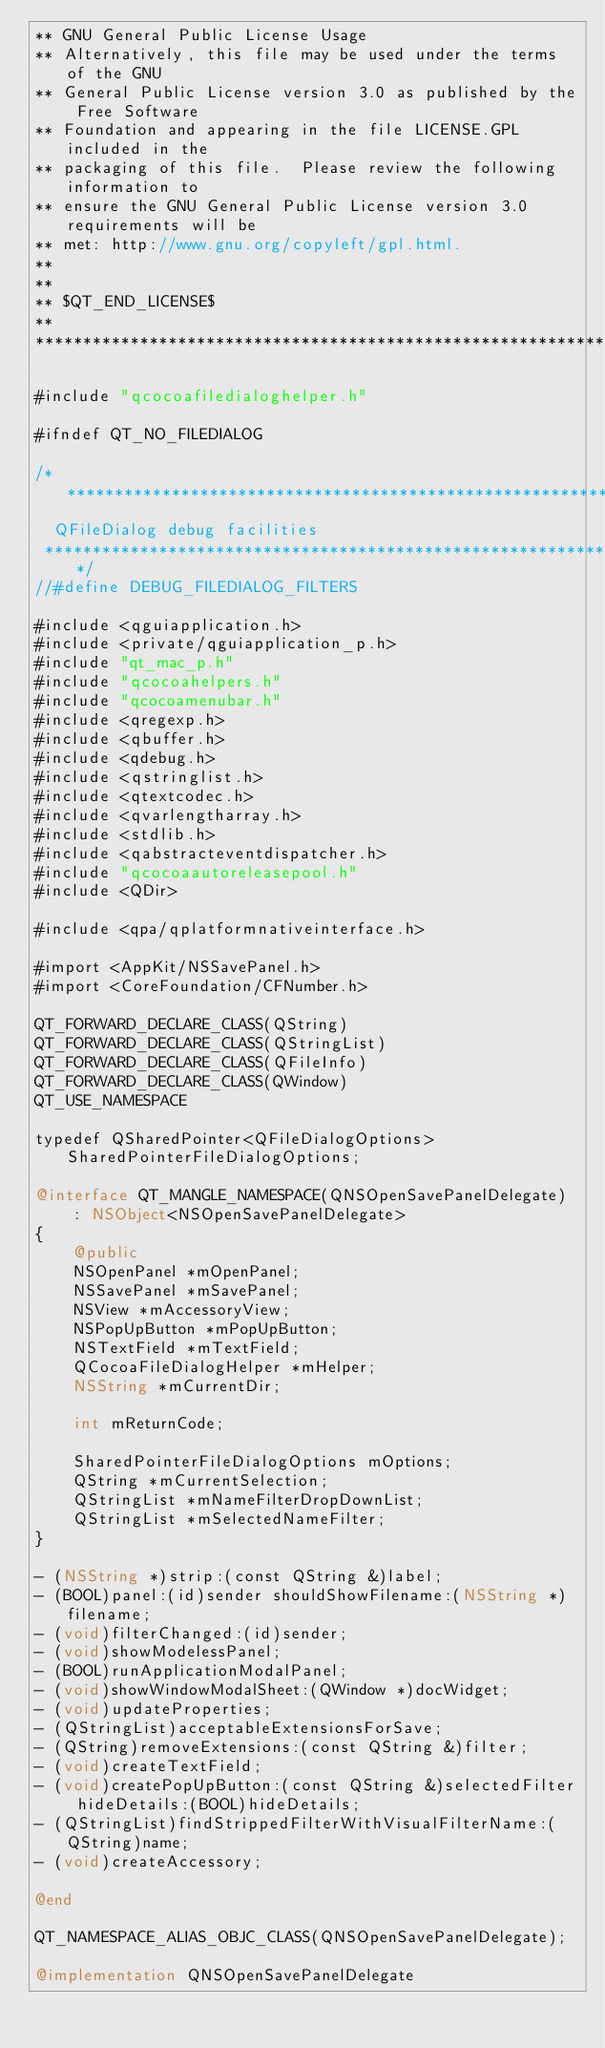Convert code to text. <code><loc_0><loc_0><loc_500><loc_500><_ObjectiveC_>** GNU General Public License Usage
** Alternatively, this file may be used under the terms of the GNU
** General Public License version 3.0 as published by the Free Software
** Foundation and appearing in the file LICENSE.GPL included in the
** packaging of this file.  Please review the following information to
** ensure the GNU General Public License version 3.0 requirements will be
** met: http://www.gnu.org/copyleft/gpl.html.
**
**
** $QT_END_LICENSE$
**
****************************************************************************/

#include "qcocoafiledialoghelper.h"

#ifndef QT_NO_FILEDIALOG

/*****************************************************************************
  QFileDialog debug facilities
 *****************************************************************************/
//#define DEBUG_FILEDIALOG_FILTERS

#include <qguiapplication.h>
#include <private/qguiapplication_p.h>
#include "qt_mac_p.h"
#include "qcocoahelpers.h"
#include "qcocoamenubar.h"
#include <qregexp.h>
#include <qbuffer.h>
#include <qdebug.h>
#include <qstringlist.h>
#include <qtextcodec.h>
#include <qvarlengtharray.h>
#include <stdlib.h>
#include <qabstracteventdispatcher.h>
#include "qcocoaautoreleasepool.h"
#include <QDir>

#include <qpa/qplatformnativeinterface.h>

#import <AppKit/NSSavePanel.h>
#import <CoreFoundation/CFNumber.h>

QT_FORWARD_DECLARE_CLASS(QString)
QT_FORWARD_DECLARE_CLASS(QStringList)
QT_FORWARD_DECLARE_CLASS(QFileInfo)
QT_FORWARD_DECLARE_CLASS(QWindow)
QT_USE_NAMESPACE

typedef QSharedPointer<QFileDialogOptions> SharedPointerFileDialogOptions;

@interface QT_MANGLE_NAMESPACE(QNSOpenSavePanelDelegate)
    : NSObject<NSOpenSavePanelDelegate>
{
    @public
    NSOpenPanel *mOpenPanel;
    NSSavePanel *mSavePanel;
    NSView *mAccessoryView;
    NSPopUpButton *mPopUpButton;
    NSTextField *mTextField;
    QCocoaFileDialogHelper *mHelper;
    NSString *mCurrentDir;

    int mReturnCode;

    SharedPointerFileDialogOptions mOptions;
    QString *mCurrentSelection;
    QStringList *mNameFilterDropDownList;
    QStringList *mSelectedNameFilter;
}

- (NSString *)strip:(const QString &)label;
- (BOOL)panel:(id)sender shouldShowFilename:(NSString *)filename;
- (void)filterChanged:(id)sender;
- (void)showModelessPanel;
- (BOOL)runApplicationModalPanel;
- (void)showWindowModalSheet:(QWindow *)docWidget;
- (void)updateProperties;
- (QStringList)acceptableExtensionsForSave;
- (QString)removeExtensions:(const QString &)filter;
- (void)createTextField;
- (void)createPopUpButton:(const QString &)selectedFilter hideDetails:(BOOL)hideDetails;
- (QStringList)findStrippedFilterWithVisualFilterName:(QString)name;
- (void)createAccessory;

@end

QT_NAMESPACE_ALIAS_OBJC_CLASS(QNSOpenSavePanelDelegate);

@implementation QNSOpenSavePanelDelegate
</code> 